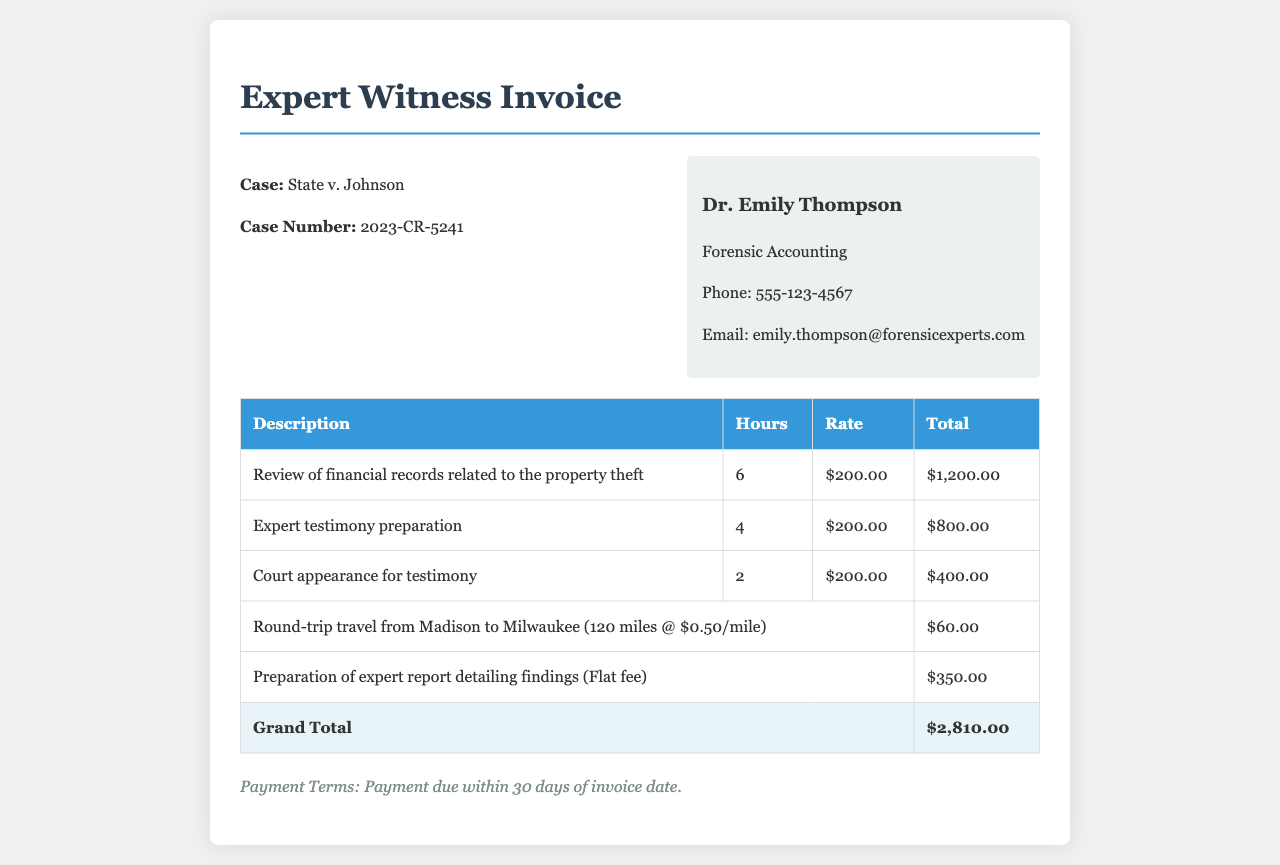What is the case number? The case number is explicitly stated in the document under the case header.
Answer: 2023-CR-5241 Who is the expert witness? The expert witness's name is presented prominently at the top of the invoice.
Answer: Dr. Emily Thompson What hourly rate is charged for expert witness services? The hourly rate is detailed in the invoice table under the Rate column for each service.
Answer: $200.00 How many hours were spent on the review of financial records? The number of hours is specified in the document for that particular service.
Answer: 6 What is the total amount for court appearance testimony? The total amount for this specific service is provided in the invoice table under Total.
Answer: $400.00 What is the total travel expense? The travel expense is listed in the invoice as a separate line item in the table.
Answer: $60.00 What is the flat fee for the preparation of the expert report? The flat fee is specifically mentioned alongside the description in the invoice table.
Answer: $350.00 What is the grand total for all services provided? The grand total is calculated and presented at the end of the invoice, summarizing all costs.
Answer: $2,810.00 What are the payment terms stated in the invoice? The payment terms are clearly outlined at the bottom of the invoice.
Answer: Payment due within 30 days of invoice date 